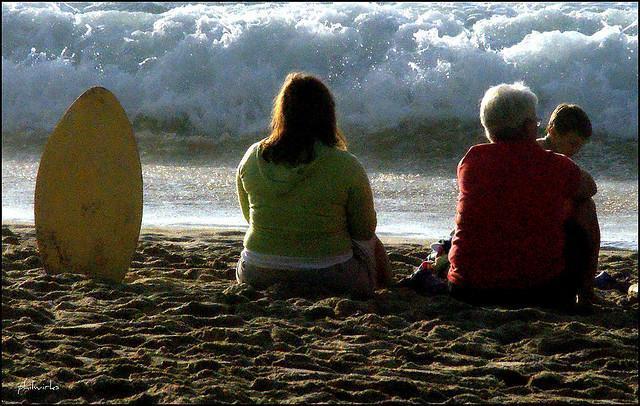How many people can you see?
Give a very brief answer. 2. 